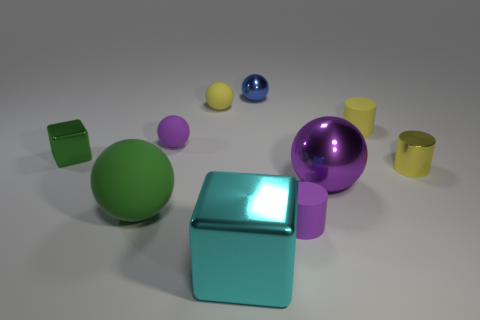Subtract 1 spheres. How many spheres are left? 4 Subtract all yellow spheres. How many spheres are left? 4 Subtract all tiny metal spheres. How many spheres are left? 4 Subtract all gray spheres. Subtract all purple cylinders. How many spheres are left? 5 Subtract all blocks. How many objects are left? 8 Add 1 red shiny balls. How many red shiny balls exist? 1 Subtract 0 green cylinders. How many objects are left? 10 Subtract all big cyan metallic cylinders. Subtract all cylinders. How many objects are left? 7 Add 2 green metal blocks. How many green metal blocks are left? 3 